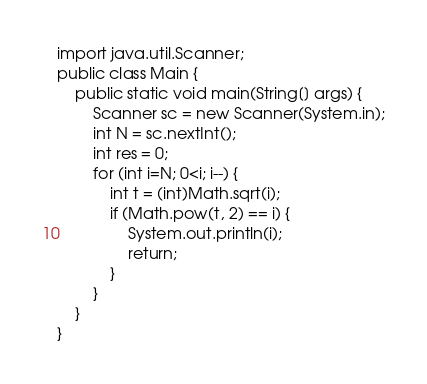<code> <loc_0><loc_0><loc_500><loc_500><_Java_>import java.util.Scanner;
public class Main {
	public static void main(String[] args) {
		Scanner sc = new Scanner(System.in);
		int N = sc.nextInt();
		int res = 0;
		for (int i=N; 0<i; i--) {
			int t = (int)Math.sqrt(i);
			if (Math.pow(t, 2) == i) {
				System.out.println(i);
				return;
			}
		}
	}
}
</code> 